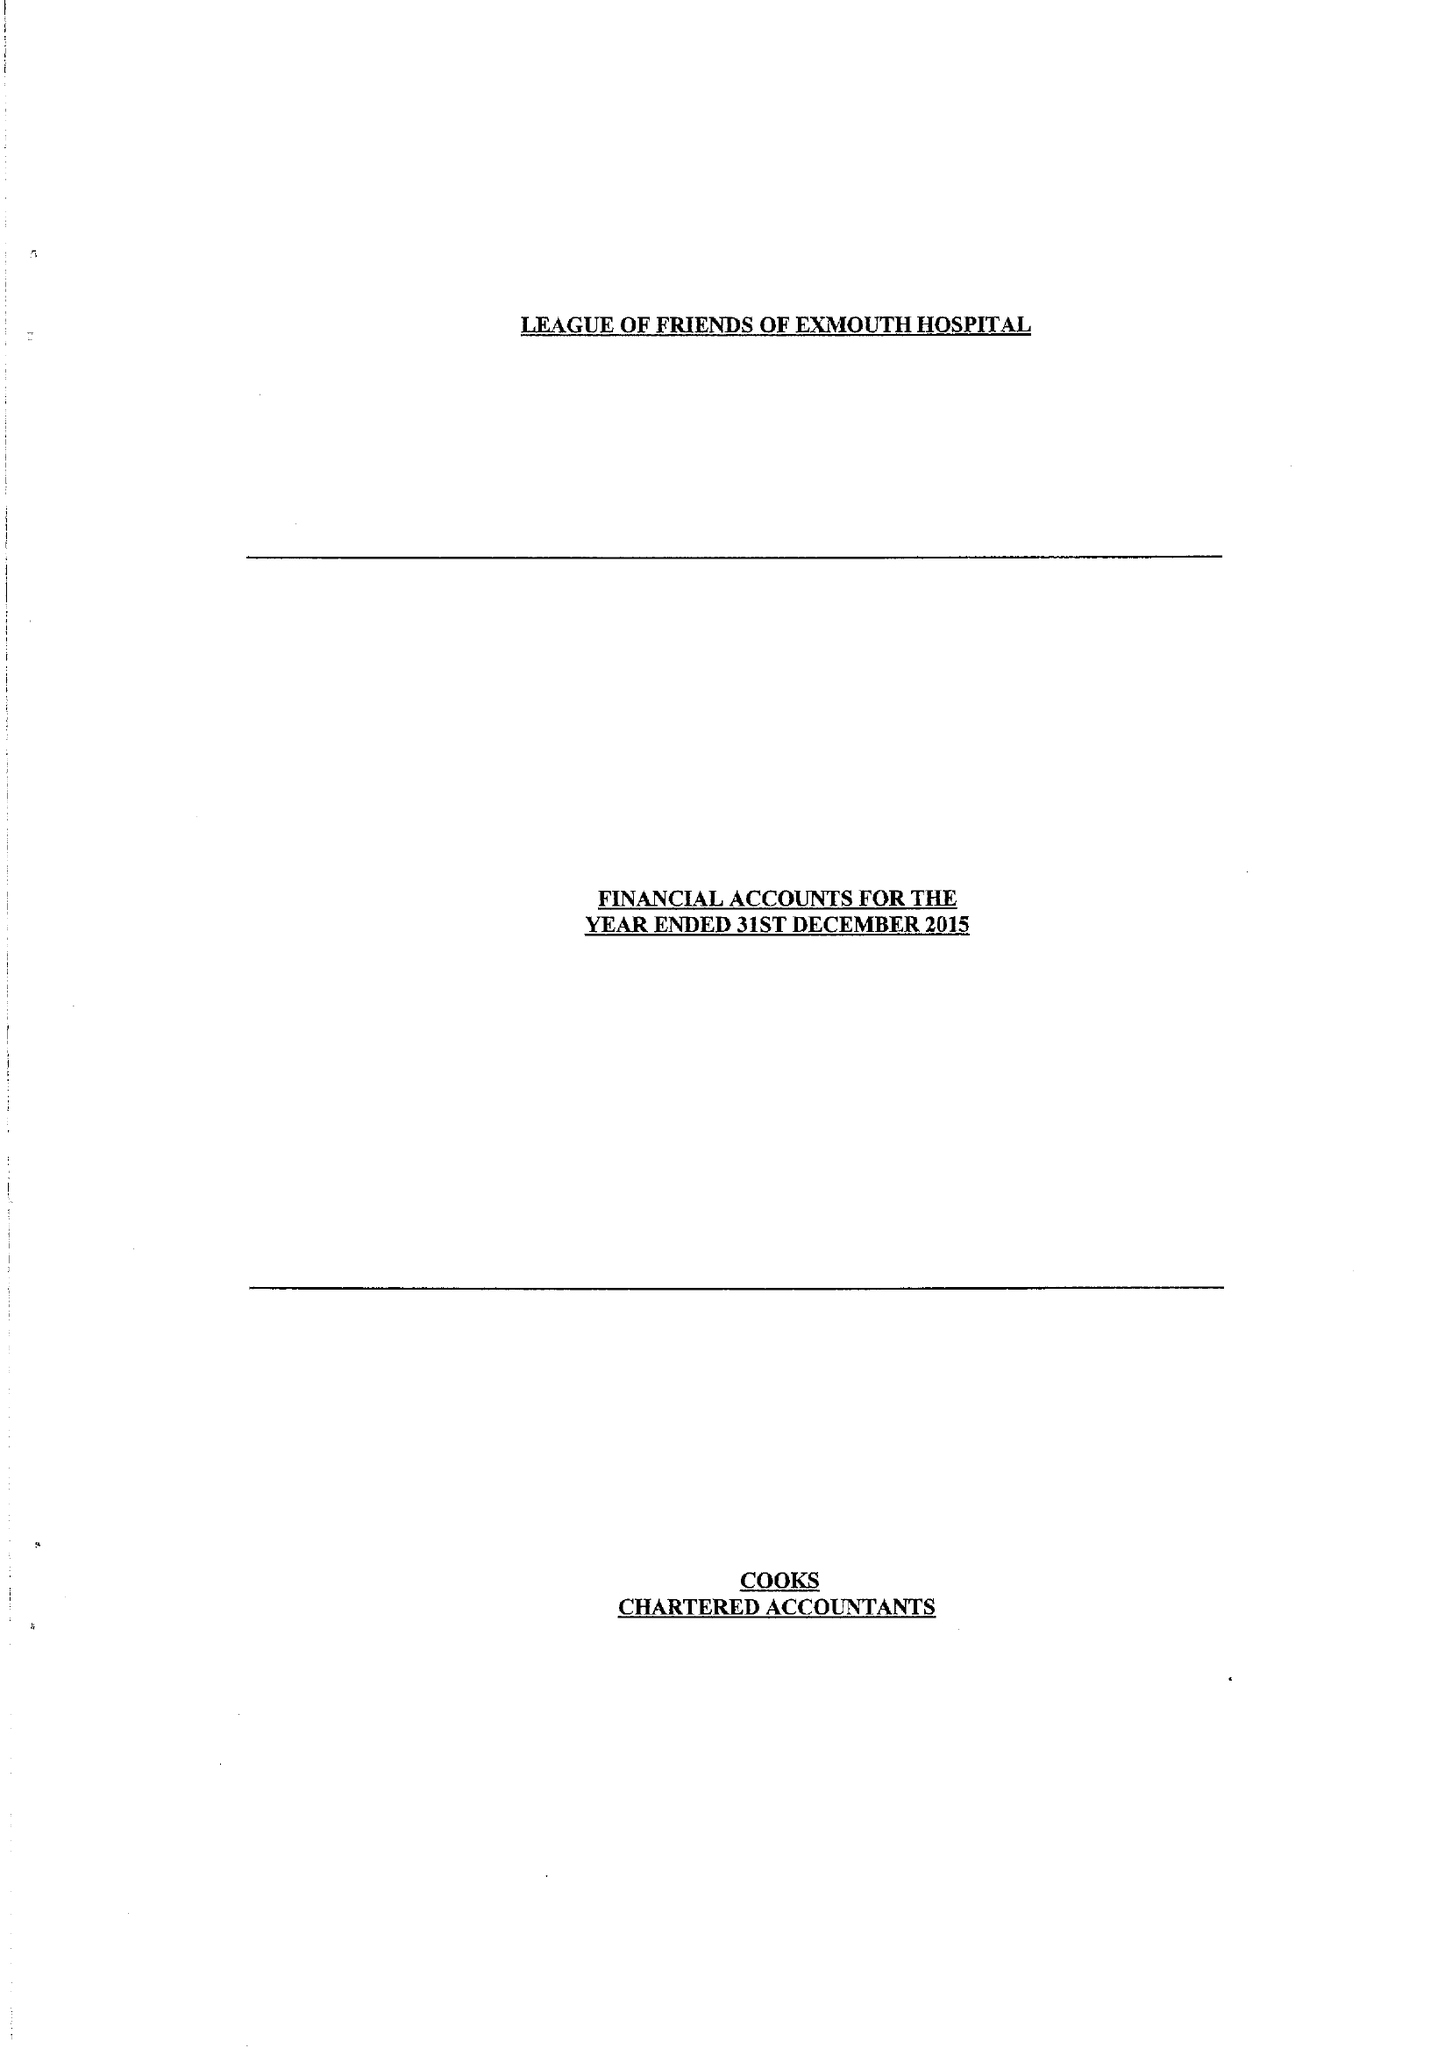What is the value for the charity_number?
Answer the question using a single word or phrase. 254353 